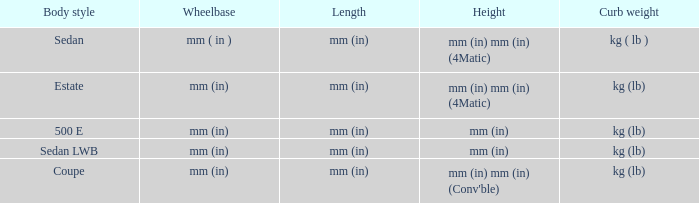What are the lengths of the models that are mm (in) tall? Mm (in), mm (in). 